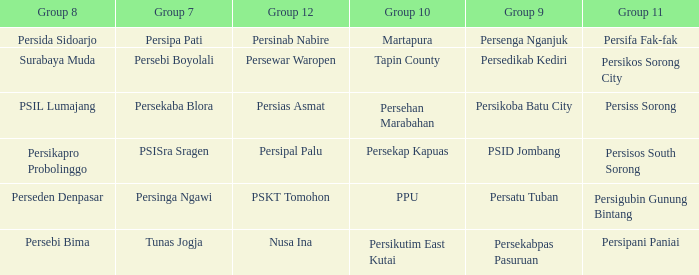Who played in group 12 when Group 9 played psid jombang? Persipal Palu. 